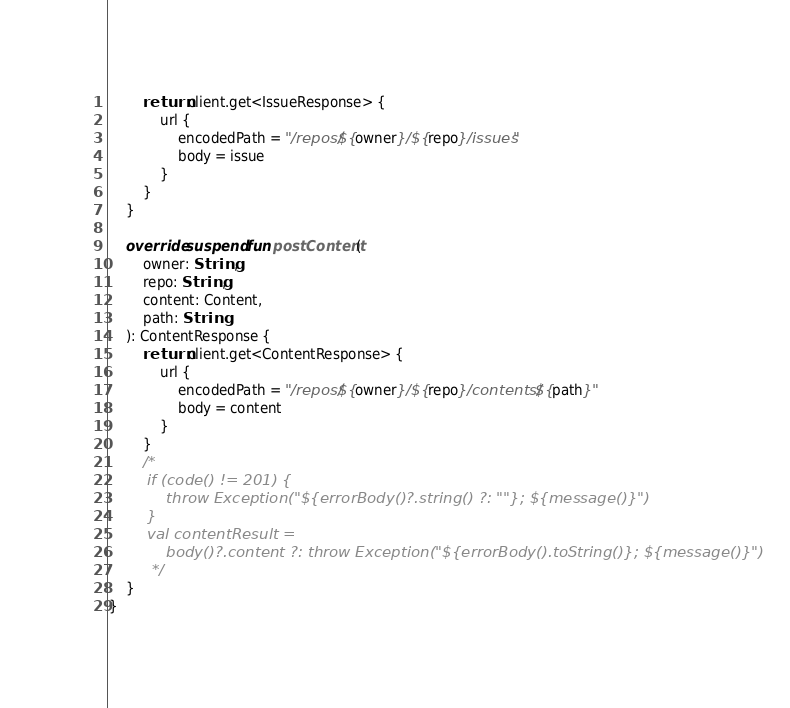Convert code to text. <code><loc_0><loc_0><loc_500><loc_500><_Kotlin_>        return client.get<IssueResponse> {
            url {
                encodedPath = "/repos/${owner}/${repo}/issues"
                body = issue
            }
        }
    }

    override suspend fun postContent(
        owner: String,
        repo: String,
        content: Content,
        path: String
    ): ContentResponse {
        return client.get<ContentResponse> {
            url {
                encodedPath = "/repos/${owner}/${repo}/contents/${path}"
                body = content
            }
        }
        /*
        if (code() != 201) {
            throw Exception("${errorBody()?.string() ?: ""}; ${message()}")
        }
        val contentResult =
            body()?.content ?: throw Exception("${errorBody().toString()}; ${message()}")
         */
    }
}
</code> 